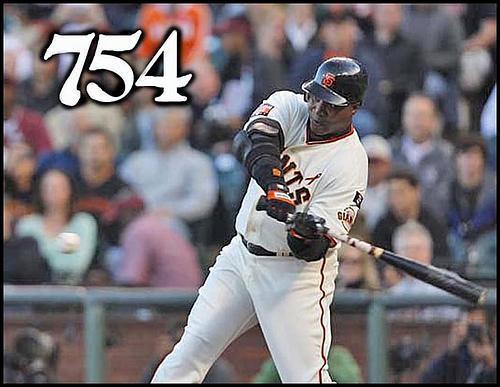How many people are in the photo?
Give a very brief answer. 6. How many donuts are in the picture?
Give a very brief answer. 0. 